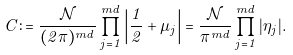<formula> <loc_0><loc_0><loc_500><loc_500>C \colon = \frac { \mathcal { N } } { ( 2 \pi ) ^ { m d } } \prod _ { j = 1 } ^ { m d } \left | \frac { 1 } { 2 } + \mu _ { j } \right | = \frac { \mathcal { N } } { \pi ^ { m d } } \prod _ { j = 1 } ^ { m d } | \eta _ { j } | .</formula> 